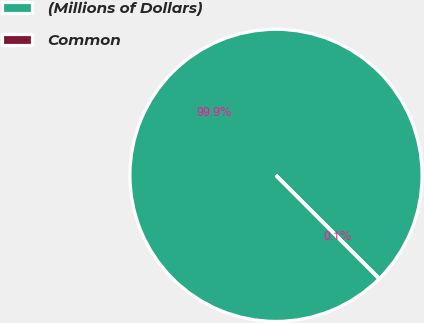Convert chart. <chart><loc_0><loc_0><loc_500><loc_500><pie_chart><fcel>(Millions of Dollars)<fcel>Common<nl><fcel>99.95%<fcel>0.05%<nl></chart> 